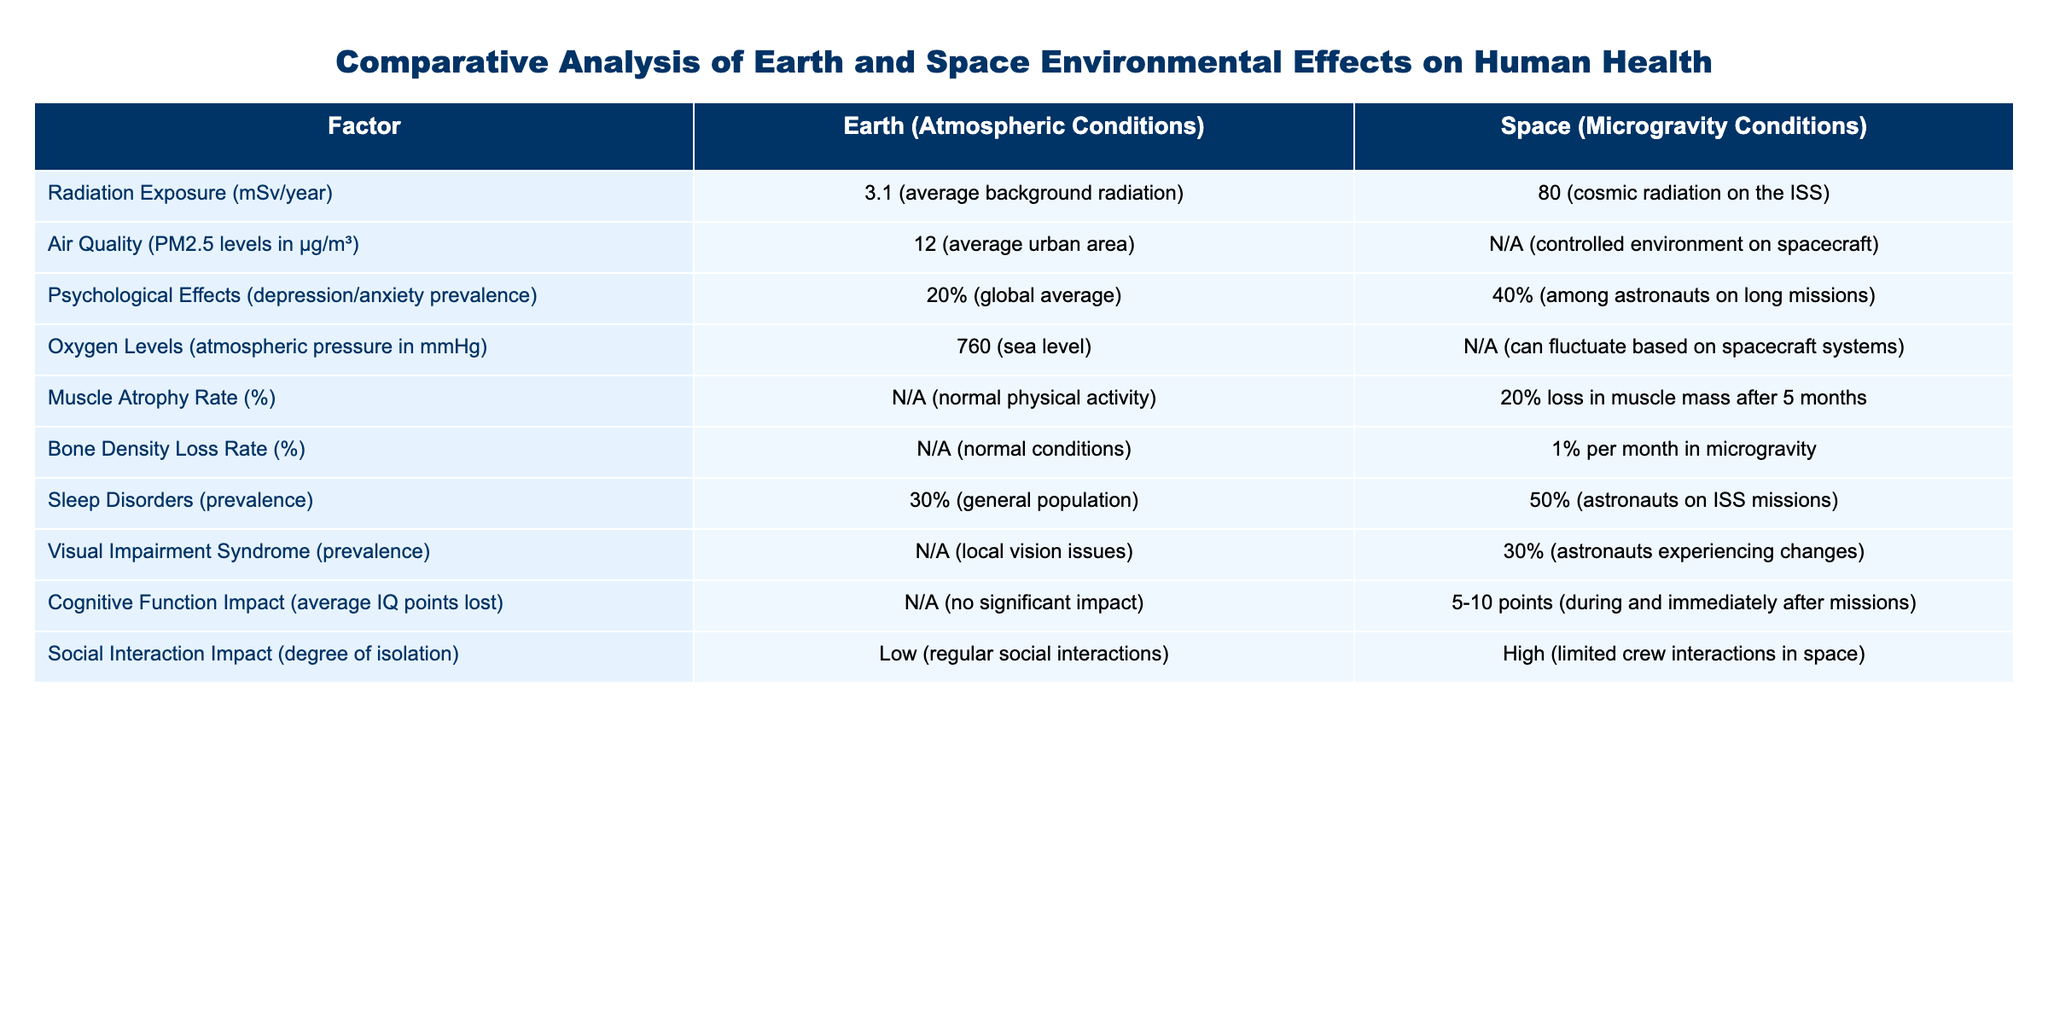What's the radiation exposure on Earth? The table indicates that the radiation exposure on Earth is 3.1 mSv/year as an average background radiation.
Answer: 3.1 mSv/year What is the muscle atrophy rate in space? The table shows that in space, the muscle atrophy rate is 20% loss in muscle mass after 5 months, indicating a significant impact.
Answer: 20% Which environment has a higher prevalence of sleep disorders? According to the table, 50% of astronauts on ISS missions experience sleep disorders, compared to 30% in the general population on Earth, indicating higher prevalence in space.
Answer: Space How does the bone density loss rate in space compare to conditions on Earth? The table shows that there is a 1% bone density loss per month in space, whereas there is no bone density loss in normal Earth conditions, suggesting a significant difference.
Answer: 1% loss per month in space What is the difference in depression/anxiety prevalence between Earth and space? The prevalence of depression/anxiety is 20% on Earth and 40% in space, resulting in a difference of 20 percentage points.
Answer: 20 percentage points Is the air quality measured in space? The table indicates that air quality is not applicable in space, as it is a controlled environment on spacecraft, meaning no PM2.5 levels are reported.
Answer: No What is the average IQ loss for astronauts during space missions? The table states that astronauts may experience an average IQ loss of 5-10 points during and immediately after missions, highlighting cognitive impacts in space.
Answer: 5-10 points If the prevalence of psychological effects is higher in space, by how much is it greater compared to Earth? The prevalence of psychological effects is 40% in space and 20% on Earth, which signifies an increase of 20 percentage points for astronauts.
Answer: 20 percentage points What overall impact does location have on social interaction? The table suggests that social interaction on Earth is low due to regular interactions, whereas in space, it is high due to limited crew interactions. Thus, the impact is significant.
Answer: Significant impact Is there any visual impairment syndrome reported on Earth? The table does not list any prevalence of visual impairment syndrome on Earth, only noting 30% prevalence among astronauts in space. Therefore, the answer is negative for Earth.
Answer: No 